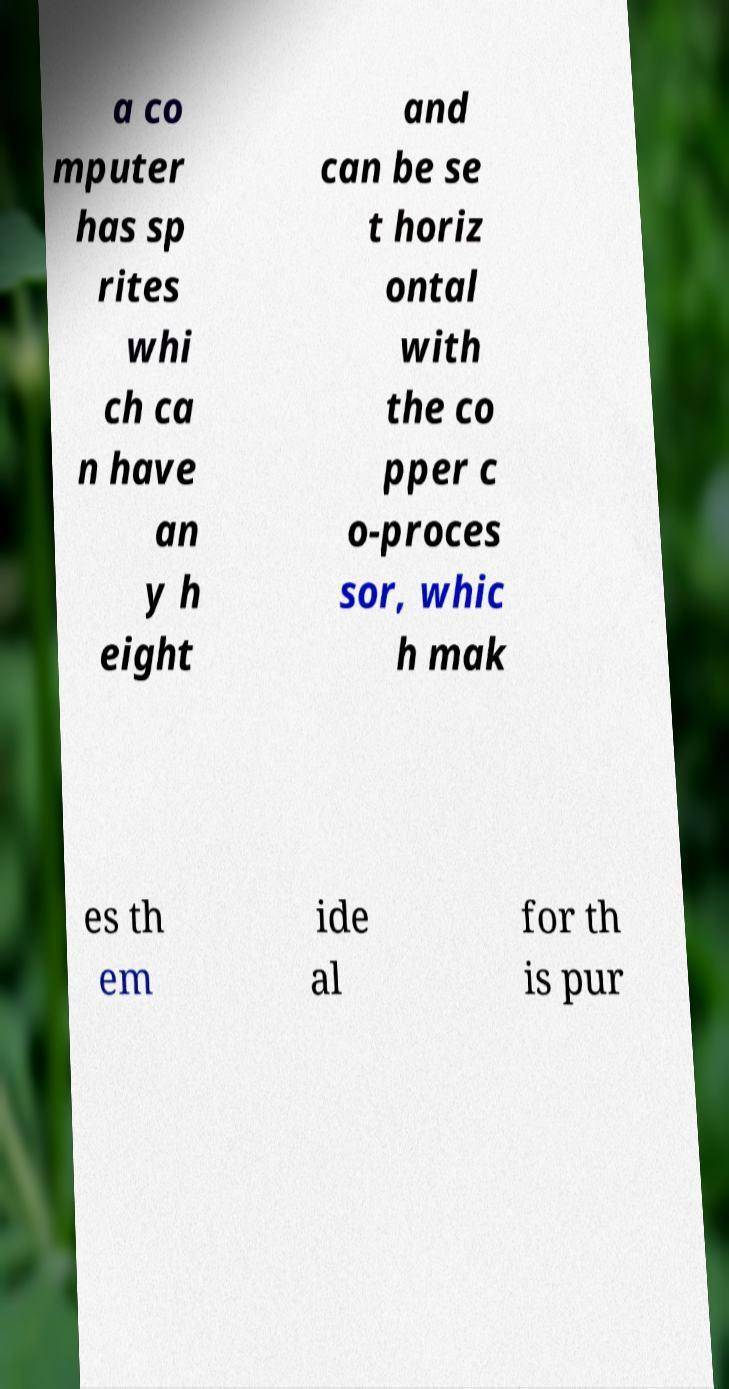Please identify and transcribe the text found in this image. a co mputer has sp rites whi ch ca n have an y h eight and can be se t horiz ontal with the co pper c o-proces sor, whic h mak es th em ide al for th is pur 